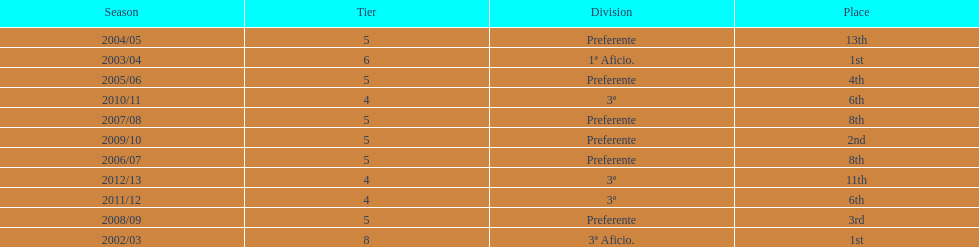What is the total number of times internacional de madrid cf finished their season as the leader of their division? 2. 